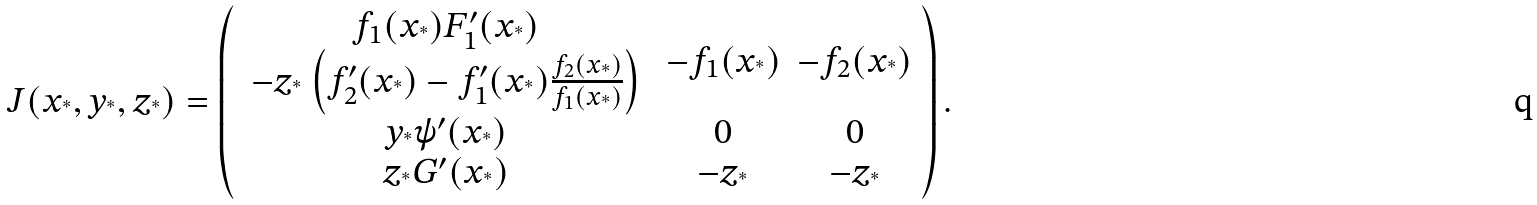<formula> <loc_0><loc_0><loc_500><loc_500>J ( x _ { ^ { * } } , y _ { ^ { * } } , z _ { ^ { * } } ) = \left ( \begin{array} { c c c } \begin{array} { c } f _ { 1 } ( x _ { ^ { * } } ) F _ { 1 } ^ { \prime } ( x _ { ^ { * } } ) \\ - z _ { ^ { * } } \left ( f _ { 2 } ^ { \prime } ( x _ { ^ { * } } ) - f _ { 1 } ^ { \prime } ( x _ { ^ { * } } ) \frac { f _ { 2 } ( x _ { ^ { * } } ) } { f _ { 1 } ( x _ { ^ { * } } ) } \right ) \end{array} & - f _ { 1 } ( x _ { ^ { * } } ) & - f _ { 2 } ( x _ { ^ { * } } ) \\ y _ { ^ { * } } \psi ^ { \prime } ( x _ { ^ { * } } ) & 0 & 0 \\ z _ { ^ { * } } G ^ { \prime } ( x _ { ^ { * } } ) & - z _ { ^ { * } } & - z _ { ^ { * } } \end{array} \right ) .</formula> 